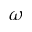Convert formula to latex. <formula><loc_0><loc_0><loc_500><loc_500>\omega</formula> 